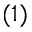<formula> <loc_0><loc_0><loc_500><loc_500>( 1 )</formula> 